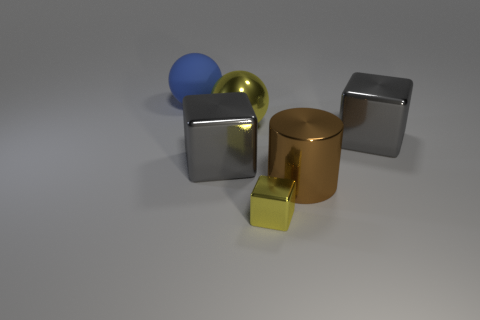What is the color of the metal thing that is the same shape as the blue rubber object? yellow 